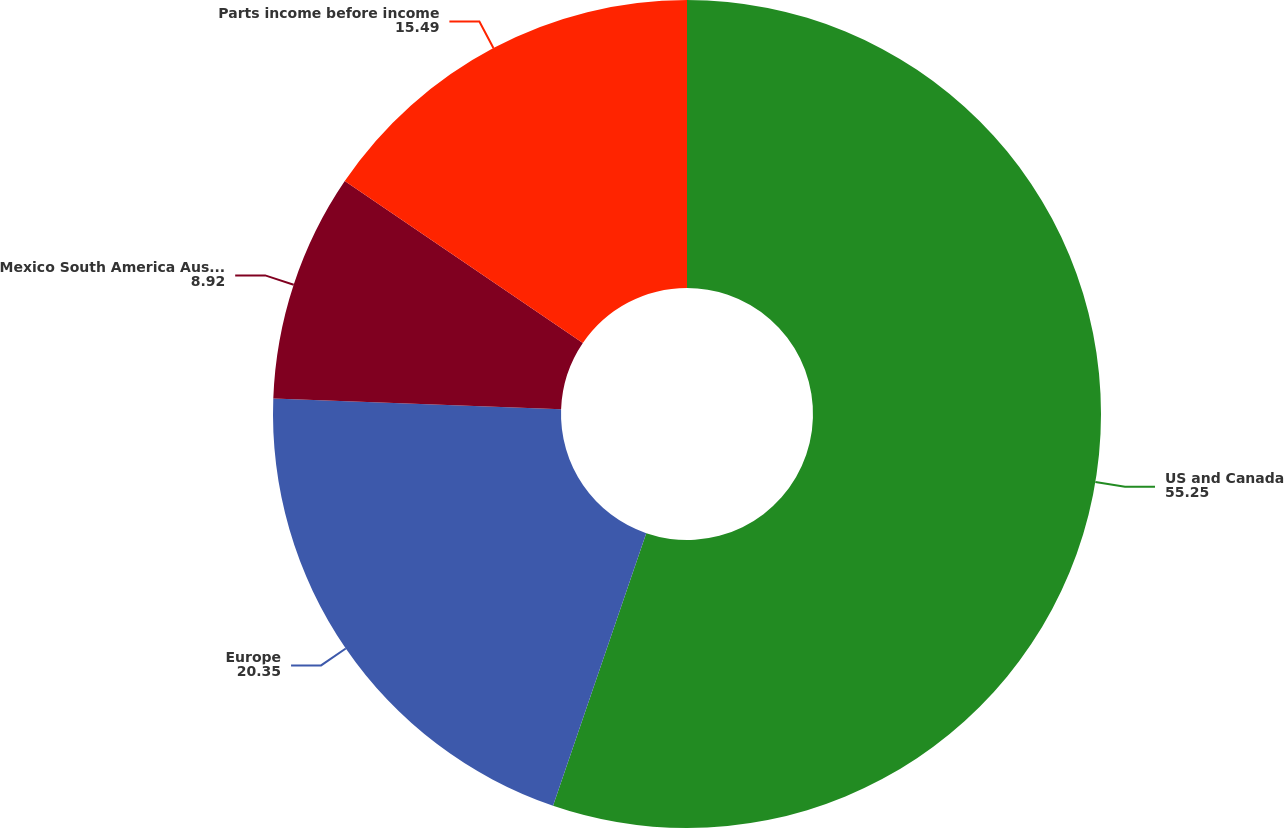<chart> <loc_0><loc_0><loc_500><loc_500><pie_chart><fcel>US and Canada<fcel>Europe<fcel>Mexico South America Australia<fcel>Parts income before income<nl><fcel>55.25%<fcel>20.35%<fcel>8.92%<fcel>15.49%<nl></chart> 